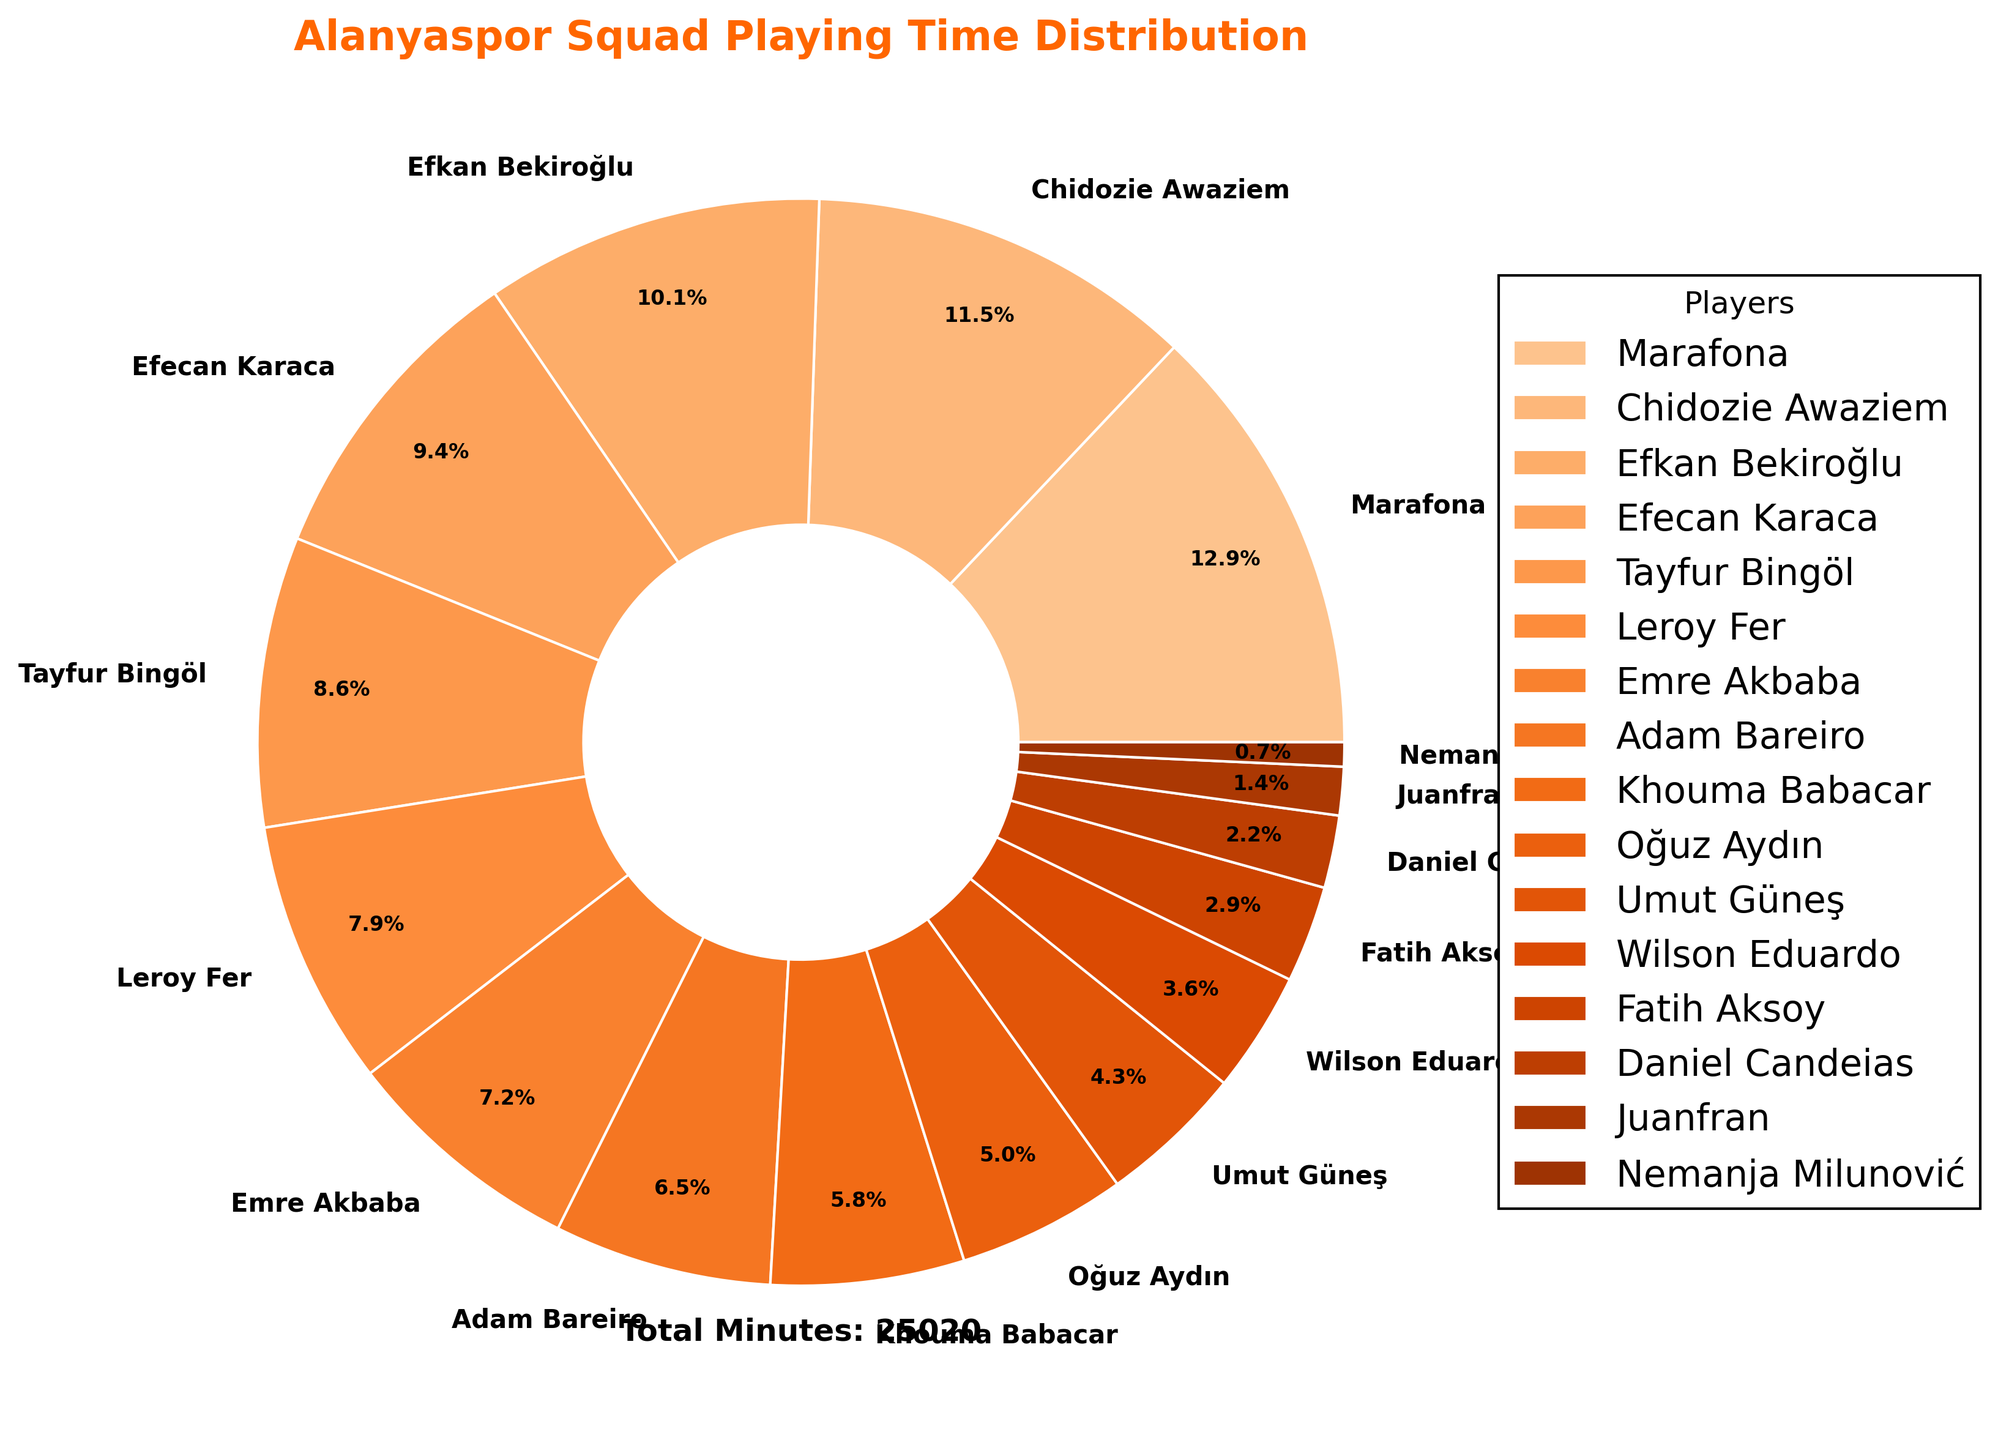What percentage of the total playing time did Marafona account for? To find the percentage, divide Marafona's minutes played (3240) by the total minutes played by the team and multiply by 100. The total minutes are the sum of all players' minutes.
Answer: 20.8% Which player played the least number of minutes? By examining the pie chart, find the player with the smallest wedge.
Answer: Nemanja Milunović How much more playing time did Chidozie Awaziem have compared to Fatih Aksoy? Subtract Fatih Aksoy's minutes (720) from Chidozie Awaziem's minutes (2880).
Answer: 2160 Who logged more minutes, Efecan Karaca or Tayfur Bingöl? Compare the slices representing Efecan Karaca and Tayfur Bingöl and see which slice is larger.
Answer: Efecan Karaca What is the combined percentage of minutes played by Emre Akbaba and Adam Bareiro? Add the minutes played by Emre Akbaba (1800) and Adam Bareiro (1620) and divide by the total minutes, then multiply by 100.
Answer: 21.8% What quarter of the total playing time did the top three players (Marafona, Chidozie Awaziem, and Efkan Bekiroğlu) occupy? Sum the minutes of Marafona, Chidozie Awaziem, and Efkan Bekiroğlu and divide by the total minutes played, then multiply by 100.
Answer: 42% Which player’s playing time is closest to the average minutes played by the entire squad? First, find the average playing time by dividing the total minutes by the number of players. Then find the player whose minutes are closest to this average.
Answer: Tayfur Bingöl Who played more minutes, Oğuz Aydın or Umut Güneş, and by how much? Compare the minutes played by Oğuz Aydın (1260) and Umut Güneş (1080), then subtract the smaller value from the larger one.
Answer: Oğuz Aydın by 180 minutes What percentage of the total playing time did the three least active players (Juanfran, Nemanja Milunović, and Fatih Aksoy) collectively contribute? Sum the minutes of Juanfran (360), Nemanja Milunović (180), and Fatih Aksoy (720), divide by the total minutes, and multiply by 100.
Answer: 4.3% Between Leroy Fer and Khouma Babacar, who had a more significant role in the playing time, and by what percentage difference? Compare the percentages of playing time by Leroy Fer (1980) and Khouma Babacar (1440). Find the difference and divide by the total playing time, then multiply by 100.
Answer: Leroy Fer by 6.1% 